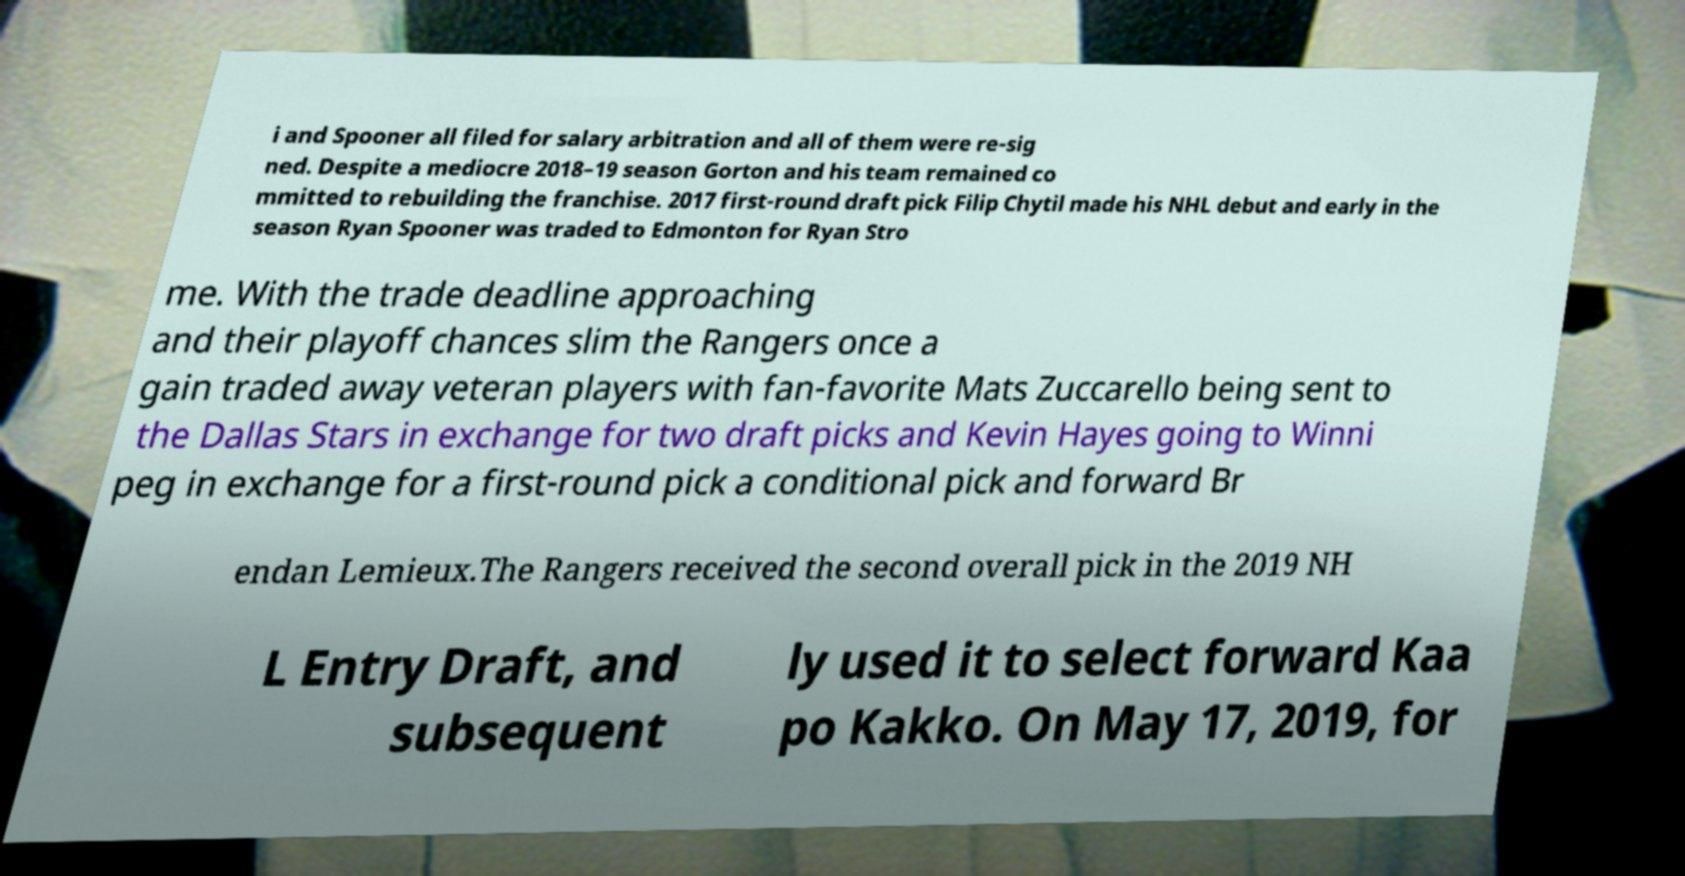What messages or text are displayed in this image? I need them in a readable, typed format. i and Spooner all filed for salary arbitration and all of them were re-sig ned. Despite a mediocre 2018–19 season Gorton and his team remained co mmitted to rebuilding the franchise. 2017 first-round draft pick Filip Chytil made his NHL debut and early in the season Ryan Spooner was traded to Edmonton for Ryan Stro me. With the trade deadline approaching and their playoff chances slim the Rangers once a gain traded away veteran players with fan-favorite Mats Zuccarello being sent to the Dallas Stars in exchange for two draft picks and Kevin Hayes going to Winni peg in exchange for a first-round pick a conditional pick and forward Br endan Lemieux.The Rangers received the second overall pick in the 2019 NH L Entry Draft, and subsequent ly used it to select forward Kaa po Kakko. On May 17, 2019, for 